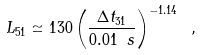Convert formula to latex. <formula><loc_0><loc_0><loc_500><loc_500>L _ { 5 1 } \simeq 1 3 0 \left ( \frac { \Delta t _ { 3 1 } } { 0 . 0 1 \ s } \right ) ^ { - 1 . 1 4 } \ ,</formula> 